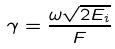Convert formula to latex. <formula><loc_0><loc_0><loc_500><loc_500>\gamma = \frac { \omega \sqrt { 2 E _ { i } } } { F }</formula> 